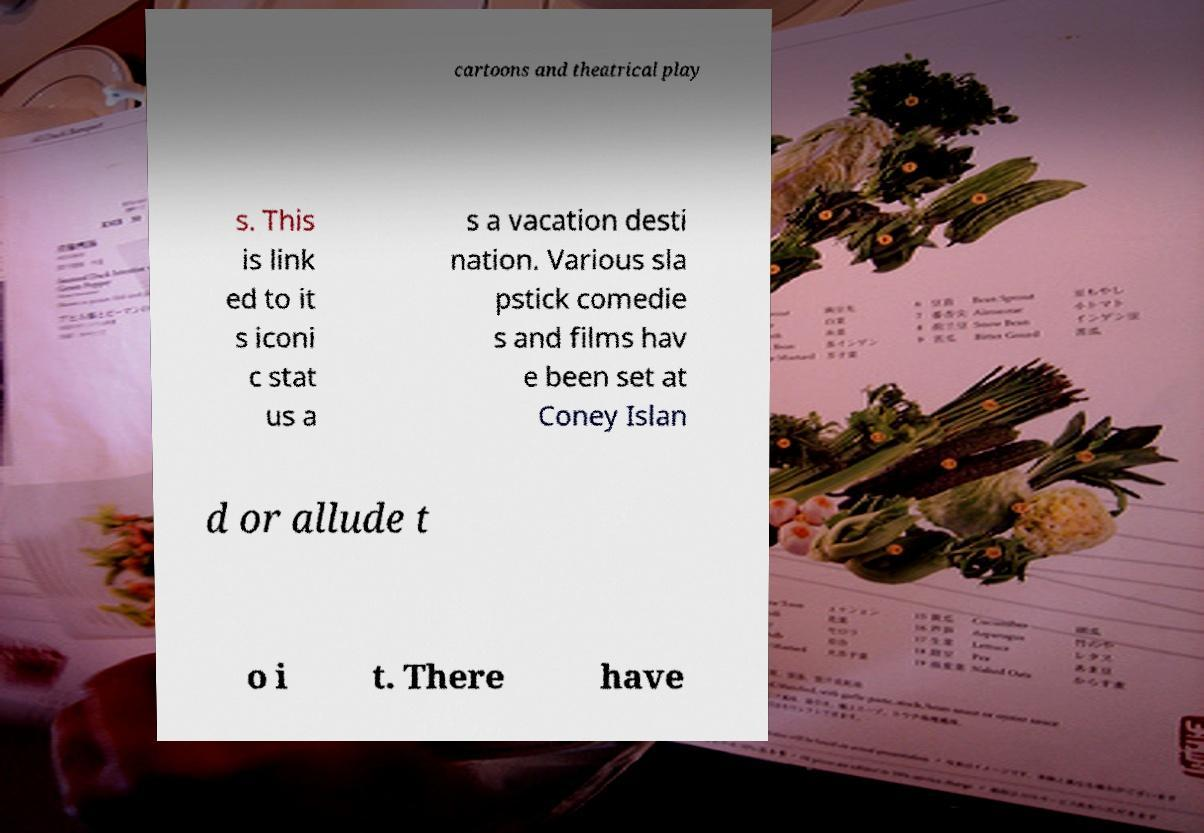What messages or text are displayed in this image? I need them in a readable, typed format. cartoons and theatrical play s. This is link ed to it s iconi c stat us a s a vacation desti nation. Various sla pstick comedie s and films hav e been set at Coney Islan d or allude t o i t. There have 